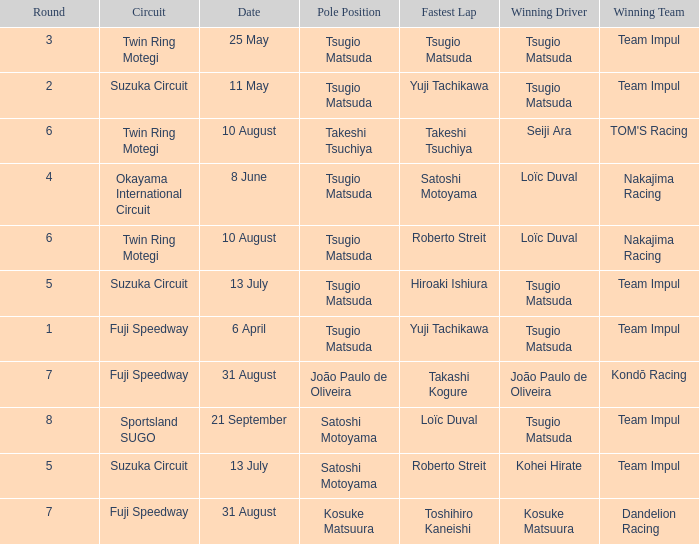What is the fastest lap for Seiji Ara? Takeshi Tsuchiya. 